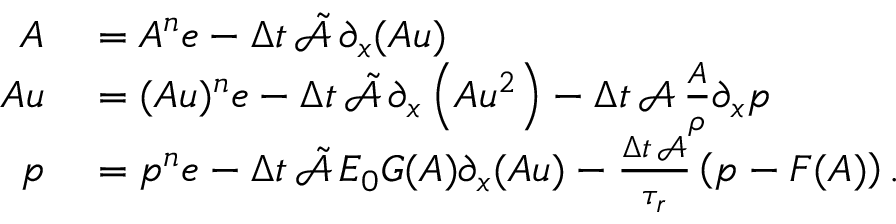Convert formula to latex. <formula><loc_0><loc_0><loc_500><loc_500>\begin{array} { r l } { A } & = A ^ { n } e - \Delta t \, \tilde { \mathcal { A } } \, \partial _ { x } ( A u ) } \\ { A u } & = ( A u ) ^ { n } e - \Delta t \, \tilde { \mathcal { A } } \, \partial _ { x } \left ( A u ^ { 2 } \right ) - \Delta t \, \mathcal { A } \, \frac { A } { \rho } \partial _ { x } p } \\ { p } & = p ^ { n } e - \Delta t \, \tilde { \mathcal { A } } \, E _ { 0 } G ( A ) \partial _ { x } ( A u ) - \frac { \Delta t \, \mathcal { A } } { \tau _ { r } } \left ( p - F ( A ) \right ) . } \end{array}</formula> 